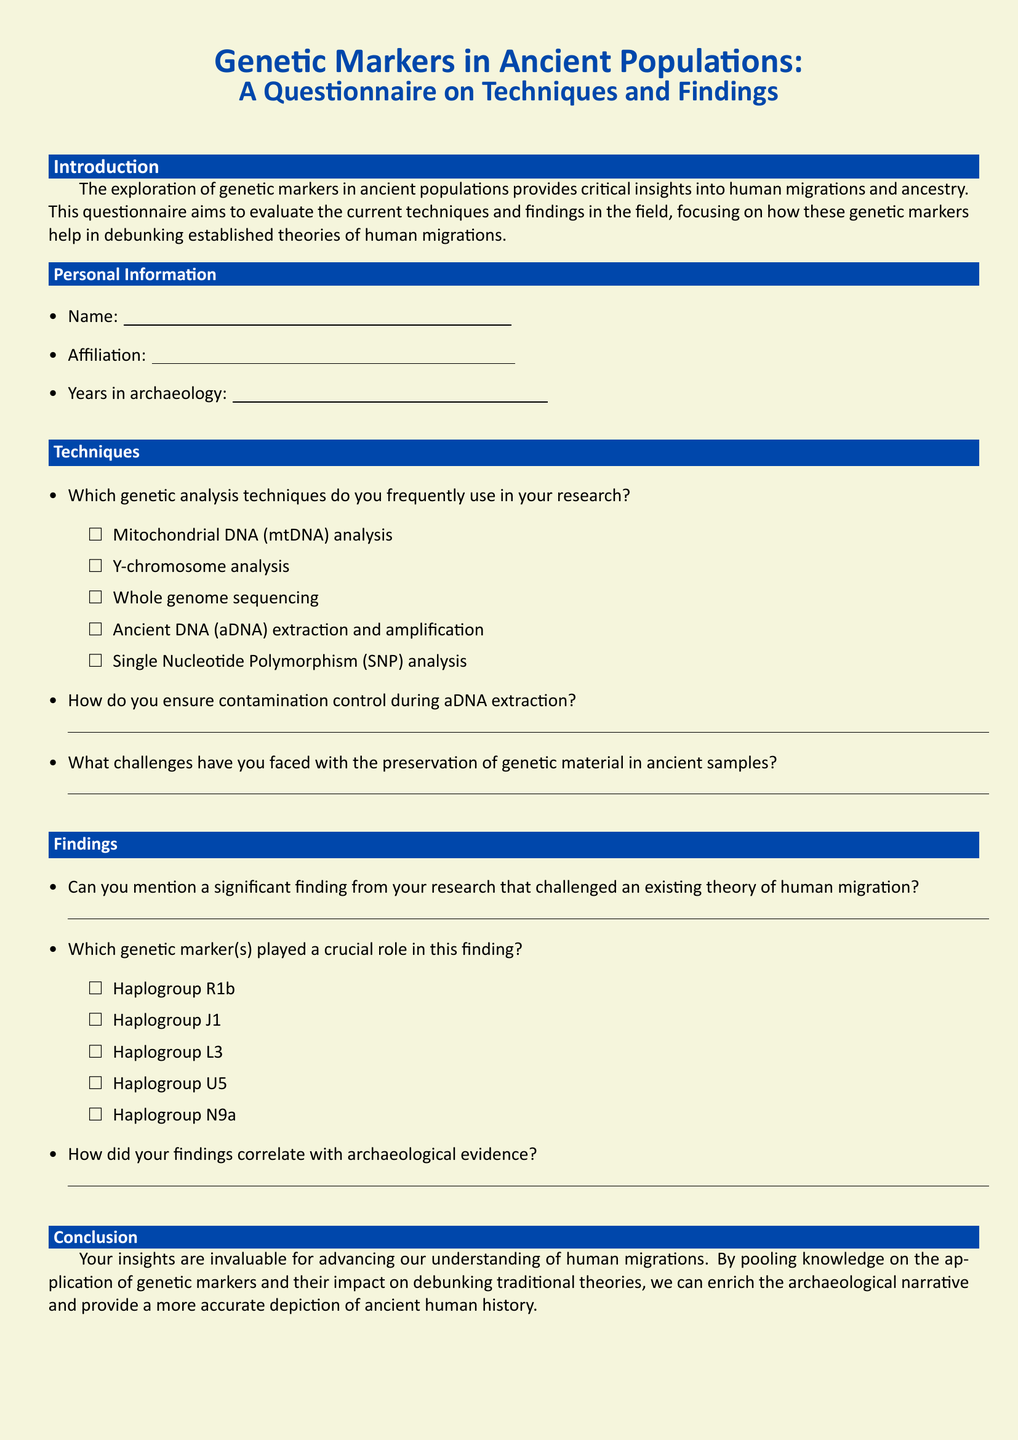What is the main focus of the questionnaire? The questionnaire aims to evaluate the current techniques and findings in the field of genetic markers and their role in human migrations.
Answer: Genetic markers and human migrations Which genetic analysis technique is mentioned for aDNA extraction? The document lists several techniques, and specifically mentions ancient DNA extraction and amplification.
Answer: Ancient DNA extraction and amplification What color is used for the background of the document? The document specifies the page color as beige, which is indicated by the RGB values.
Answer: Beige Which genetic marker is not listed in the document? The question requires identifying a genetic marker not mentioned among the options provided for significant findings.
Answer: None (all listed) How does the questionnaire contribute to archaeological understanding? The conclusion explains that the insights help to enrich the archaeological narrative and provide a more accurate depiction of ancient human history.
Answer: Enrich archaeological narrative What is the purpose of ensuring contamination control during aDNA extraction? The question is asking for the reason for implementing contamination control measures, which is generally to maintain sample integrity.
Answer: Maintain sample integrity 